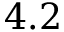<formula> <loc_0><loc_0><loc_500><loc_500>4 . 2</formula> 